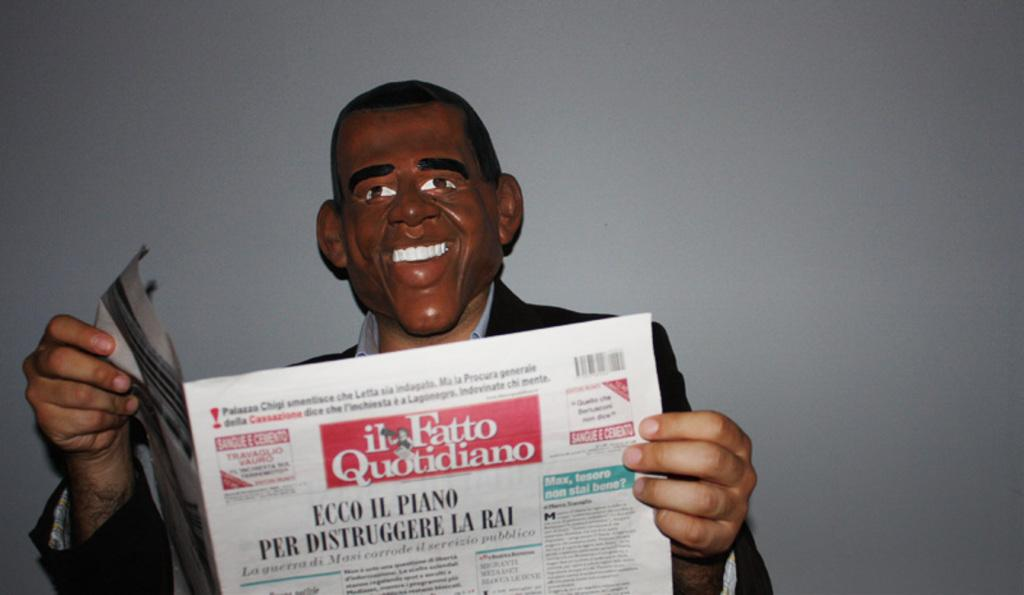Where was the image taken? The image is taken indoors. What can be seen in the background of the image? There is a wall in the background of the image. Who is the main subject in the image? There is a man in the middle of the image. What is the man wearing? The man is wearing a face mask. What is the man doing in the image? The man is reading a newspaper. How many nails can be seen sticking out of the wall in the image? There are no nails visible in the image; only a wall is present in the background. What type of stick is the man using to read the newspaper in the image? There is no stick present in the image; the man is reading the newspaper without any visible tools or aids. 